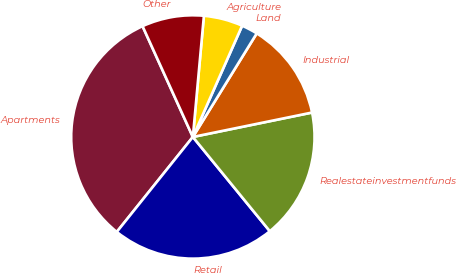Convert chart. <chart><loc_0><loc_0><loc_500><loc_500><pie_chart><fcel>Apartments<fcel>Retail<fcel>Realestateinvestmentfunds<fcel>Industrial<fcel>Land<fcel>Agriculture<fcel>Other<nl><fcel>32.47%<fcel>21.65%<fcel>17.32%<fcel>12.99%<fcel>2.16%<fcel>5.19%<fcel>8.23%<nl></chart> 